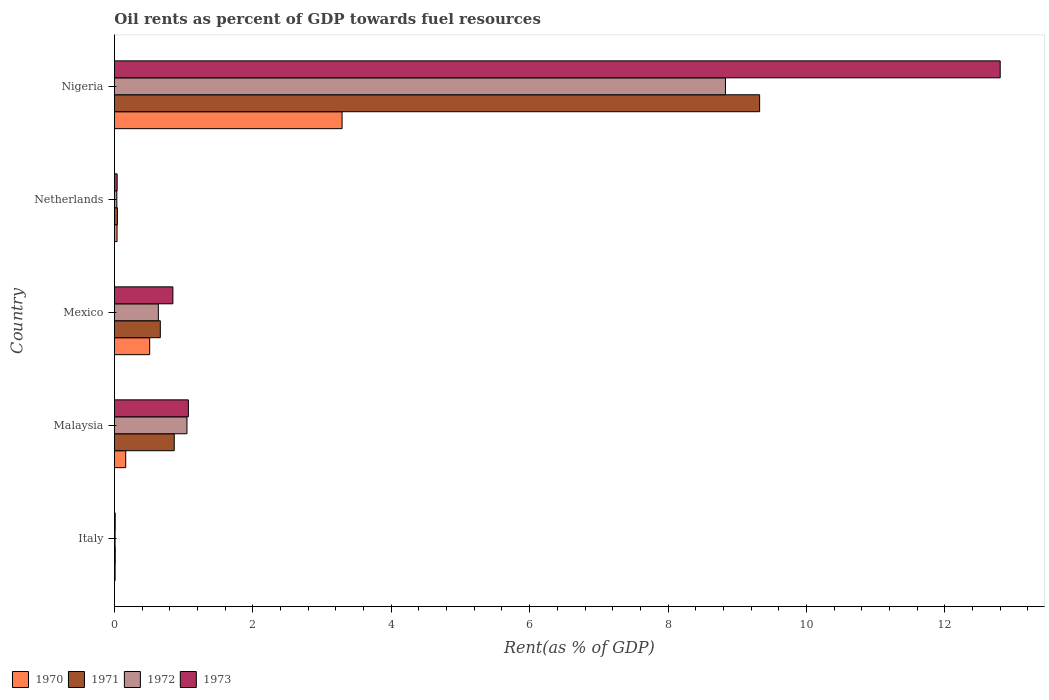How many different coloured bars are there?
Keep it short and to the point. 4. How many groups of bars are there?
Provide a succinct answer. 5. Are the number of bars on each tick of the Y-axis equal?
Give a very brief answer. Yes. How many bars are there on the 5th tick from the bottom?
Give a very brief answer. 4. What is the label of the 3rd group of bars from the top?
Give a very brief answer. Mexico. What is the oil rent in 1972 in Netherlands?
Your response must be concise. 0.03. Across all countries, what is the maximum oil rent in 1972?
Your response must be concise. 8.83. Across all countries, what is the minimum oil rent in 1973?
Ensure brevity in your answer.  0.01. In which country was the oil rent in 1972 maximum?
Provide a succinct answer. Nigeria. What is the total oil rent in 1972 in the graph?
Keep it short and to the point. 10.56. What is the difference between the oil rent in 1971 in Mexico and that in Netherlands?
Your answer should be compact. 0.62. What is the difference between the oil rent in 1973 in Nigeria and the oil rent in 1971 in Italy?
Offer a very short reply. 12.79. What is the average oil rent in 1970 per country?
Ensure brevity in your answer.  0.8. What is the difference between the oil rent in 1972 and oil rent in 1973 in Mexico?
Give a very brief answer. -0.21. In how many countries, is the oil rent in 1970 greater than 6.4 %?
Make the answer very short. 0. What is the ratio of the oil rent in 1970 in Malaysia to that in Nigeria?
Give a very brief answer. 0.05. Is the oil rent in 1970 in Italy less than that in Nigeria?
Offer a very short reply. Yes. What is the difference between the highest and the second highest oil rent in 1970?
Your answer should be very brief. 2.78. What is the difference between the highest and the lowest oil rent in 1971?
Ensure brevity in your answer.  9.31. In how many countries, is the oil rent in 1971 greater than the average oil rent in 1971 taken over all countries?
Your answer should be very brief. 1. Is it the case that in every country, the sum of the oil rent in 1973 and oil rent in 1972 is greater than the sum of oil rent in 1970 and oil rent in 1971?
Ensure brevity in your answer.  No. What does the 3rd bar from the bottom in Nigeria represents?
Offer a terse response. 1972. How many bars are there?
Your answer should be compact. 20. Are all the bars in the graph horizontal?
Ensure brevity in your answer.  Yes. How many countries are there in the graph?
Provide a short and direct response. 5. What is the difference between two consecutive major ticks on the X-axis?
Provide a succinct answer. 2. Does the graph contain any zero values?
Provide a succinct answer. No. What is the title of the graph?
Give a very brief answer. Oil rents as percent of GDP towards fuel resources. Does "1967" appear as one of the legend labels in the graph?
Your answer should be very brief. No. What is the label or title of the X-axis?
Make the answer very short. Rent(as % of GDP). What is the Rent(as % of GDP) in 1970 in Italy?
Make the answer very short. 0.01. What is the Rent(as % of GDP) of 1971 in Italy?
Keep it short and to the point. 0.01. What is the Rent(as % of GDP) in 1972 in Italy?
Your response must be concise. 0.01. What is the Rent(as % of GDP) of 1973 in Italy?
Provide a succinct answer. 0.01. What is the Rent(as % of GDP) of 1970 in Malaysia?
Your answer should be compact. 0.16. What is the Rent(as % of GDP) in 1971 in Malaysia?
Keep it short and to the point. 0.86. What is the Rent(as % of GDP) in 1972 in Malaysia?
Provide a short and direct response. 1.05. What is the Rent(as % of GDP) in 1973 in Malaysia?
Keep it short and to the point. 1.07. What is the Rent(as % of GDP) of 1970 in Mexico?
Make the answer very short. 0.51. What is the Rent(as % of GDP) in 1971 in Mexico?
Ensure brevity in your answer.  0.66. What is the Rent(as % of GDP) in 1972 in Mexico?
Offer a very short reply. 0.63. What is the Rent(as % of GDP) in 1973 in Mexico?
Provide a short and direct response. 0.84. What is the Rent(as % of GDP) in 1970 in Netherlands?
Provide a short and direct response. 0.04. What is the Rent(as % of GDP) of 1971 in Netherlands?
Ensure brevity in your answer.  0.04. What is the Rent(as % of GDP) of 1972 in Netherlands?
Your answer should be compact. 0.03. What is the Rent(as % of GDP) of 1973 in Netherlands?
Your response must be concise. 0.04. What is the Rent(as % of GDP) in 1970 in Nigeria?
Your answer should be compact. 3.29. What is the Rent(as % of GDP) in 1971 in Nigeria?
Offer a very short reply. 9.32. What is the Rent(as % of GDP) in 1972 in Nigeria?
Your answer should be very brief. 8.83. What is the Rent(as % of GDP) in 1973 in Nigeria?
Offer a terse response. 12.8. Across all countries, what is the maximum Rent(as % of GDP) in 1970?
Provide a succinct answer. 3.29. Across all countries, what is the maximum Rent(as % of GDP) in 1971?
Keep it short and to the point. 9.32. Across all countries, what is the maximum Rent(as % of GDP) of 1972?
Ensure brevity in your answer.  8.83. Across all countries, what is the maximum Rent(as % of GDP) of 1973?
Make the answer very short. 12.8. Across all countries, what is the minimum Rent(as % of GDP) in 1970?
Your answer should be compact. 0.01. Across all countries, what is the minimum Rent(as % of GDP) in 1971?
Offer a very short reply. 0.01. Across all countries, what is the minimum Rent(as % of GDP) in 1972?
Keep it short and to the point. 0.01. Across all countries, what is the minimum Rent(as % of GDP) of 1973?
Your answer should be very brief. 0.01. What is the total Rent(as % of GDP) of 1970 in the graph?
Make the answer very short. 4.01. What is the total Rent(as % of GDP) in 1971 in the graph?
Make the answer very short. 10.91. What is the total Rent(as % of GDP) in 1972 in the graph?
Ensure brevity in your answer.  10.56. What is the total Rent(as % of GDP) of 1973 in the graph?
Offer a terse response. 14.76. What is the difference between the Rent(as % of GDP) in 1970 in Italy and that in Malaysia?
Your answer should be very brief. -0.15. What is the difference between the Rent(as % of GDP) of 1971 in Italy and that in Malaysia?
Provide a short and direct response. -0.85. What is the difference between the Rent(as % of GDP) of 1972 in Italy and that in Malaysia?
Your answer should be compact. -1.04. What is the difference between the Rent(as % of GDP) in 1973 in Italy and that in Malaysia?
Your response must be concise. -1.06. What is the difference between the Rent(as % of GDP) in 1970 in Italy and that in Mexico?
Your response must be concise. -0.5. What is the difference between the Rent(as % of GDP) of 1971 in Italy and that in Mexico?
Keep it short and to the point. -0.65. What is the difference between the Rent(as % of GDP) in 1972 in Italy and that in Mexico?
Provide a short and direct response. -0.63. What is the difference between the Rent(as % of GDP) of 1973 in Italy and that in Mexico?
Provide a succinct answer. -0.83. What is the difference between the Rent(as % of GDP) in 1970 in Italy and that in Netherlands?
Give a very brief answer. -0.03. What is the difference between the Rent(as % of GDP) in 1971 in Italy and that in Netherlands?
Make the answer very short. -0.03. What is the difference between the Rent(as % of GDP) in 1972 in Italy and that in Netherlands?
Provide a succinct answer. -0.03. What is the difference between the Rent(as % of GDP) of 1973 in Italy and that in Netherlands?
Provide a succinct answer. -0.03. What is the difference between the Rent(as % of GDP) in 1970 in Italy and that in Nigeria?
Make the answer very short. -3.28. What is the difference between the Rent(as % of GDP) of 1971 in Italy and that in Nigeria?
Your answer should be very brief. -9.31. What is the difference between the Rent(as % of GDP) of 1972 in Italy and that in Nigeria?
Provide a succinct answer. -8.82. What is the difference between the Rent(as % of GDP) of 1973 in Italy and that in Nigeria?
Offer a very short reply. -12.79. What is the difference between the Rent(as % of GDP) in 1970 in Malaysia and that in Mexico?
Your response must be concise. -0.35. What is the difference between the Rent(as % of GDP) of 1971 in Malaysia and that in Mexico?
Keep it short and to the point. 0.2. What is the difference between the Rent(as % of GDP) in 1972 in Malaysia and that in Mexico?
Give a very brief answer. 0.41. What is the difference between the Rent(as % of GDP) in 1973 in Malaysia and that in Mexico?
Keep it short and to the point. 0.22. What is the difference between the Rent(as % of GDP) in 1970 in Malaysia and that in Netherlands?
Provide a succinct answer. 0.13. What is the difference between the Rent(as % of GDP) of 1971 in Malaysia and that in Netherlands?
Ensure brevity in your answer.  0.82. What is the difference between the Rent(as % of GDP) of 1972 in Malaysia and that in Netherlands?
Your answer should be compact. 1.01. What is the difference between the Rent(as % of GDP) in 1973 in Malaysia and that in Netherlands?
Ensure brevity in your answer.  1.03. What is the difference between the Rent(as % of GDP) of 1970 in Malaysia and that in Nigeria?
Keep it short and to the point. -3.13. What is the difference between the Rent(as % of GDP) of 1971 in Malaysia and that in Nigeria?
Ensure brevity in your answer.  -8.46. What is the difference between the Rent(as % of GDP) of 1972 in Malaysia and that in Nigeria?
Ensure brevity in your answer.  -7.78. What is the difference between the Rent(as % of GDP) of 1973 in Malaysia and that in Nigeria?
Make the answer very short. -11.73. What is the difference between the Rent(as % of GDP) of 1970 in Mexico and that in Netherlands?
Your response must be concise. 0.47. What is the difference between the Rent(as % of GDP) in 1971 in Mexico and that in Netherlands?
Offer a terse response. 0.62. What is the difference between the Rent(as % of GDP) in 1972 in Mexico and that in Netherlands?
Provide a succinct answer. 0.6. What is the difference between the Rent(as % of GDP) of 1973 in Mexico and that in Netherlands?
Your response must be concise. 0.81. What is the difference between the Rent(as % of GDP) of 1970 in Mexico and that in Nigeria?
Your response must be concise. -2.78. What is the difference between the Rent(as % of GDP) in 1971 in Mexico and that in Nigeria?
Keep it short and to the point. -8.66. What is the difference between the Rent(as % of GDP) in 1972 in Mexico and that in Nigeria?
Ensure brevity in your answer.  -8.19. What is the difference between the Rent(as % of GDP) in 1973 in Mexico and that in Nigeria?
Make the answer very short. -11.95. What is the difference between the Rent(as % of GDP) in 1970 in Netherlands and that in Nigeria?
Your answer should be very brief. -3.25. What is the difference between the Rent(as % of GDP) of 1971 in Netherlands and that in Nigeria?
Your answer should be very brief. -9.28. What is the difference between the Rent(as % of GDP) in 1972 in Netherlands and that in Nigeria?
Provide a short and direct response. -8.79. What is the difference between the Rent(as % of GDP) of 1973 in Netherlands and that in Nigeria?
Your answer should be very brief. -12.76. What is the difference between the Rent(as % of GDP) in 1970 in Italy and the Rent(as % of GDP) in 1971 in Malaysia?
Keep it short and to the point. -0.85. What is the difference between the Rent(as % of GDP) of 1970 in Italy and the Rent(as % of GDP) of 1972 in Malaysia?
Offer a very short reply. -1.04. What is the difference between the Rent(as % of GDP) in 1970 in Italy and the Rent(as % of GDP) in 1973 in Malaysia?
Offer a very short reply. -1.06. What is the difference between the Rent(as % of GDP) of 1971 in Italy and the Rent(as % of GDP) of 1972 in Malaysia?
Ensure brevity in your answer.  -1.04. What is the difference between the Rent(as % of GDP) of 1971 in Italy and the Rent(as % of GDP) of 1973 in Malaysia?
Make the answer very short. -1.06. What is the difference between the Rent(as % of GDP) in 1972 in Italy and the Rent(as % of GDP) in 1973 in Malaysia?
Your answer should be compact. -1.06. What is the difference between the Rent(as % of GDP) in 1970 in Italy and the Rent(as % of GDP) in 1971 in Mexico?
Offer a terse response. -0.65. What is the difference between the Rent(as % of GDP) in 1970 in Italy and the Rent(as % of GDP) in 1972 in Mexico?
Make the answer very short. -0.62. What is the difference between the Rent(as % of GDP) of 1970 in Italy and the Rent(as % of GDP) of 1973 in Mexico?
Provide a succinct answer. -0.83. What is the difference between the Rent(as % of GDP) in 1971 in Italy and the Rent(as % of GDP) in 1972 in Mexico?
Provide a succinct answer. -0.62. What is the difference between the Rent(as % of GDP) of 1971 in Italy and the Rent(as % of GDP) of 1973 in Mexico?
Provide a succinct answer. -0.83. What is the difference between the Rent(as % of GDP) in 1972 in Italy and the Rent(as % of GDP) in 1973 in Mexico?
Make the answer very short. -0.84. What is the difference between the Rent(as % of GDP) in 1970 in Italy and the Rent(as % of GDP) in 1971 in Netherlands?
Provide a short and direct response. -0.03. What is the difference between the Rent(as % of GDP) of 1970 in Italy and the Rent(as % of GDP) of 1972 in Netherlands?
Your answer should be compact. -0.02. What is the difference between the Rent(as % of GDP) of 1970 in Italy and the Rent(as % of GDP) of 1973 in Netherlands?
Your answer should be very brief. -0.03. What is the difference between the Rent(as % of GDP) in 1971 in Italy and the Rent(as % of GDP) in 1972 in Netherlands?
Your answer should be compact. -0.02. What is the difference between the Rent(as % of GDP) in 1971 in Italy and the Rent(as % of GDP) in 1973 in Netherlands?
Offer a very short reply. -0.03. What is the difference between the Rent(as % of GDP) in 1972 in Italy and the Rent(as % of GDP) in 1973 in Netherlands?
Give a very brief answer. -0.03. What is the difference between the Rent(as % of GDP) of 1970 in Italy and the Rent(as % of GDP) of 1971 in Nigeria?
Make the answer very short. -9.31. What is the difference between the Rent(as % of GDP) in 1970 in Italy and the Rent(as % of GDP) in 1972 in Nigeria?
Make the answer very short. -8.82. What is the difference between the Rent(as % of GDP) in 1970 in Italy and the Rent(as % of GDP) in 1973 in Nigeria?
Provide a short and direct response. -12.79. What is the difference between the Rent(as % of GDP) in 1971 in Italy and the Rent(as % of GDP) in 1972 in Nigeria?
Offer a terse response. -8.82. What is the difference between the Rent(as % of GDP) of 1971 in Italy and the Rent(as % of GDP) of 1973 in Nigeria?
Give a very brief answer. -12.79. What is the difference between the Rent(as % of GDP) in 1972 in Italy and the Rent(as % of GDP) in 1973 in Nigeria?
Your answer should be very brief. -12.79. What is the difference between the Rent(as % of GDP) of 1970 in Malaysia and the Rent(as % of GDP) of 1971 in Mexico?
Give a very brief answer. -0.5. What is the difference between the Rent(as % of GDP) in 1970 in Malaysia and the Rent(as % of GDP) in 1972 in Mexico?
Provide a succinct answer. -0.47. What is the difference between the Rent(as % of GDP) in 1970 in Malaysia and the Rent(as % of GDP) in 1973 in Mexico?
Keep it short and to the point. -0.68. What is the difference between the Rent(as % of GDP) in 1971 in Malaysia and the Rent(as % of GDP) in 1972 in Mexico?
Your response must be concise. 0.23. What is the difference between the Rent(as % of GDP) of 1971 in Malaysia and the Rent(as % of GDP) of 1973 in Mexico?
Make the answer very short. 0.02. What is the difference between the Rent(as % of GDP) in 1972 in Malaysia and the Rent(as % of GDP) in 1973 in Mexico?
Offer a very short reply. 0.2. What is the difference between the Rent(as % of GDP) in 1970 in Malaysia and the Rent(as % of GDP) in 1971 in Netherlands?
Your response must be concise. 0.12. What is the difference between the Rent(as % of GDP) of 1970 in Malaysia and the Rent(as % of GDP) of 1972 in Netherlands?
Offer a very short reply. 0.13. What is the difference between the Rent(as % of GDP) in 1970 in Malaysia and the Rent(as % of GDP) in 1973 in Netherlands?
Give a very brief answer. 0.12. What is the difference between the Rent(as % of GDP) of 1971 in Malaysia and the Rent(as % of GDP) of 1972 in Netherlands?
Provide a succinct answer. 0.83. What is the difference between the Rent(as % of GDP) in 1971 in Malaysia and the Rent(as % of GDP) in 1973 in Netherlands?
Provide a short and direct response. 0.82. What is the difference between the Rent(as % of GDP) of 1972 in Malaysia and the Rent(as % of GDP) of 1973 in Netherlands?
Keep it short and to the point. 1.01. What is the difference between the Rent(as % of GDP) of 1970 in Malaysia and the Rent(as % of GDP) of 1971 in Nigeria?
Your answer should be compact. -9.16. What is the difference between the Rent(as % of GDP) of 1970 in Malaysia and the Rent(as % of GDP) of 1972 in Nigeria?
Offer a terse response. -8.67. What is the difference between the Rent(as % of GDP) of 1970 in Malaysia and the Rent(as % of GDP) of 1973 in Nigeria?
Provide a succinct answer. -12.64. What is the difference between the Rent(as % of GDP) of 1971 in Malaysia and the Rent(as % of GDP) of 1972 in Nigeria?
Provide a short and direct response. -7.96. What is the difference between the Rent(as % of GDP) of 1971 in Malaysia and the Rent(as % of GDP) of 1973 in Nigeria?
Your answer should be very brief. -11.94. What is the difference between the Rent(as % of GDP) in 1972 in Malaysia and the Rent(as % of GDP) in 1973 in Nigeria?
Your answer should be compact. -11.75. What is the difference between the Rent(as % of GDP) of 1970 in Mexico and the Rent(as % of GDP) of 1971 in Netherlands?
Keep it short and to the point. 0.47. What is the difference between the Rent(as % of GDP) in 1970 in Mexico and the Rent(as % of GDP) in 1972 in Netherlands?
Your answer should be compact. 0.47. What is the difference between the Rent(as % of GDP) of 1970 in Mexico and the Rent(as % of GDP) of 1973 in Netherlands?
Give a very brief answer. 0.47. What is the difference between the Rent(as % of GDP) in 1971 in Mexico and the Rent(as % of GDP) in 1972 in Netherlands?
Provide a short and direct response. 0.63. What is the difference between the Rent(as % of GDP) of 1971 in Mexico and the Rent(as % of GDP) of 1973 in Netherlands?
Ensure brevity in your answer.  0.62. What is the difference between the Rent(as % of GDP) of 1972 in Mexico and the Rent(as % of GDP) of 1973 in Netherlands?
Offer a very short reply. 0.6. What is the difference between the Rent(as % of GDP) in 1970 in Mexico and the Rent(as % of GDP) in 1971 in Nigeria?
Your answer should be very brief. -8.81. What is the difference between the Rent(as % of GDP) in 1970 in Mexico and the Rent(as % of GDP) in 1972 in Nigeria?
Offer a very short reply. -8.32. What is the difference between the Rent(as % of GDP) in 1970 in Mexico and the Rent(as % of GDP) in 1973 in Nigeria?
Your answer should be very brief. -12.29. What is the difference between the Rent(as % of GDP) in 1971 in Mexico and the Rent(as % of GDP) in 1972 in Nigeria?
Your answer should be very brief. -8.17. What is the difference between the Rent(as % of GDP) of 1971 in Mexico and the Rent(as % of GDP) of 1973 in Nigeria?
Your answer should be compact. -12.14. What is the difference between the Rent(as % of GDP) of 1972 in Mexico and the Rent(as % of GDP) of 1973 in Nigeria?
Keep it short and to the point. -12.16. What is the difference between the Rent(as % of GDP) of 1970 in Netherlands and the Rent(as % of GDP) of 1971 in Nigeria?
Provide a short and direct response. -9.29. What is the difference between the Rent(as % of GDP) of 1970 in Netherlands and the Rent(as % of GDP) of 1972 in Nigeria?
Your response must be concise. -8.79. What is the difference between the Rent(as % of GDP) in 1970 in Netherlands and the Rent(as % of GDP) in 1973 in Nigeria?
Make the answer very short. -12.76. What is the difference between the Rent(as % of GDP) of 1971 in Netherlands and the Rent(as % of GDP) of 1972 in Nigeria?
Provide a short and direct response. -8.79. What is the difference between the Rent(as % of GDP) of 1971 in Netherlands and the Rent(as % of GDP) of 1973 in Nigeria?
Your answer should be very brief. -12.76. What is the difference between the Rent(as % of GDP) of 1972 in Netherlands and the Rent(as % of GDP) of 1973 in Nigeria?
Ensure brevity in your answer.  -12.76. What is the average Rent(as % of GDP) in 1970 per country?
Offer a terse response. 0.8. What is the average Rent(as % of GDP) of 1971 per country?
Your answer should be compact. 2.18. What is the average Rent(as % of GDP) of 1972 per country?
Offer a terse response. 2.11. What is the average Rent(as % of GDP) in 1973 per country?
Your answer should be compact. 2.95. What is the difference between the Rent(as % of GDP) of 1970 and Rent(as % of GDP) of 1971 in Italy?
Provide a succinct answer. -0. What is the difference between the Rent(as % of GDP) in 1970 and Rent(as % of GDP) in 1972 in Italy?
Offer a very short reply. 0. What is the difference between the Rent(as % of GDP) of 1970 and Rent(as % of GDP) of 1973 in Italy?
Provide a succinct answer. -0. What is the difference between the Rent(as % of GDP) in 1971 and Rent(as % of GDP) in 1972 in Italy?
Your answer should be compact. 0. What is the difference between the Rent(as % of GDP) in 1972 and Rent(as % of GDP) in 1973 in Italy?
Ensure brevity in your answer.  -0. What is the difference between the Rent(as % of GDP) in 1970 and Rent(as % of GDP) in 1971 in Malaysia?
Offer a very short reply. -0.7. What is the difference between the Rent(as % of GDP) of 1970 and Rent(as % of GDP) of 1972 in Malaysia?
Offer a terse response. -0.89. What is the difference between the Rent(as % of GDP) of 1970 and Rent(as % of GDP) of 1973 in Malaysia?
Offer a terse response. -0.91. What is the difference between the Rent(as % of GDP) of 1971 and Rent(as % of GDP) of 1972 in Malaysia?
Your response must be concise. -0.18. What is the difference between the Rent(as % of GDP) of 1971 and Rent(as % of GDP) of 1973 in Malaysia?
Make the answer very short. -0.2. What is the difference between the Rent(as % of GDP) of 1972 and Rent(as % of GDP) of 1973 in Malaysia?
Ensure brevity in your answer.  -0.02. What is the difference between the Rent(as % of GDP) of 1970 and Rent(as % of GDP) of 1971 in Mexico?
Ensure brevity in your answer.  -0.15. What is the difference between the Rent(as % of GDP) in 1970 and Rent(as % of GDP) in 1972 in Mexico?
Your answer should be compact. -0.13. What is the difference between the Rent(as % of GDP) in 1970 and Rent(as % of GDP) in 1973 in Mexico?
Give a very brief answer. -0.34. What is the difference between the Rent(as % of GDP) in 1971 and Rent(as % of GDP) in 1972 in Mexico?
Your answer should be compact. 0.03. What is the difference between the Rent(as % of GDP) in 1971 and Rent(as % of GDP) in 1973 in Mexico?
Provide a succinct answer. -0.18. What is the difference between the Rent(as % of GDP) of 1972 and Rent(as % of GDP) of 1973 in Mexico?
Give a very brief answer. -0.21. What is the difference between the Rent(as % of GDP) of 1970 and Rent(as % of GDP) of 1971 in Netherlands?
Make the answer very short. -0.01. What is the difference between the Rent(as % of GDP) of 1970 and Rent(as % of GDP) of 1972 in Netherlands?
Ensure brevity in your answer.  0. What is the difference between the Rent(as % of GDP) in 1970 and Rent(as % of GDP) in 1973 in Netherlands?
Offer a terse response. -0. What is the difference between the Rent(as % of GDP) in 1971 and Rent(as % of GDP) in 1972 in Netherlands?
Your answer should be very brief. 0.01. What is the difference between the Rent(as % of GDP) in 1971 and Rent(as % of GDP) in 1973 in Netherlands?
Make the answer very short. 0. What is the difference between the Rent(as % of GDP) of 1972 and Rent(as % of GDP) of 1973 in Netherlands?
Offer a terse response. -0. What is the difference between the Rent(as % of GDP) in 1970 and Rent(as % of GDP) in 1971 in Nigeria?
Keep it short and to the point. -6.03. What is the difference between the Rent(as % of GDP) in 1970 and Rent(as % of GDP) in 1972 in Nigeria?
Your answer should be very brief. -5.54. What is the difference between the Rent(as % of GDP) in 1970 and Rent(as % of GDP) in 1973 in Nigeria?
Your response must be concise. -9.51. What is the difference between the Rent(as % of GDP) of 1971 and Rent(as % of GDP) of 1972 in Nigeria?
Your response must be concise. 0.49. What is the difference between the Rent(as % of GDP) of 1971 and Rent(as % of GDP) of 1973 in Nigeria?
Provide a short and direct response. -3.48. What is the difference between the Rent(as % of GDP) of 1972 and Rent(as % of GDP) of 1973 in Nigeria?
Give a very brief answer. -3.97. What is the ratio of the Rent(as % of GDP) in 1970 in Italy to that in Malaysia?
Offer a very short reply. 0.06. What is the ratio of the Rent(as % of GDP) of 1971 in Italy to that in Malaysia?
Offer a terse response. 0.01. What is the ratio of the Rent(as % of GDP) of 1972 in Italy to that in Malaysia?
Give a very brief answer. 0.01. What is the ratio of the Rent(as % of GDP) of 1973 in Italy to that in Malaysia?
Your answer should be compact. 0.01. What is the ratio of the Rent(as % of GDP) of 1970 in Italy to that in Mexico?
Your answer should be compact. 0.02. What is the ratio of the Rent(as % of GDP) in 1971 in Italy to that in Mexico?
Ensure brevity in your answer.  0.02. What is the ratio of the Rent(as % of GDP) of 1972 in Italy to that in Mexico?
Make the answer very short. 0.01. What is the ratio of the Rent(as % of GDP) of 1973 in Italy to that in Mexico?
Offer a very short reply. 0.01. What is the ratio of the Rent(as % of GDP) in 1970 in Italy to that in Netherlands?
Your answer should be compact. 0.26. What is the ratio of the Rent(as % of GDP) in 1971 in Italy to that in Netherlands?
Offer a very short reply. 0.27. What is the ratio of the Rent(as % of GDP) in 1972 in Italy to that in Netherlands?
Offer a very short reply. 0.27. What is the ratio of the Rent(as % of GDP) in 1973 in Italy to that in Netherlands?
Keep it short and to the point. 0.28. What is the ratio of the Rent(as % of GDP) of 1970 in Italy to that in Nigeria?
Keep it short and to the point. 0. What is the ratio of the Rent(as % of GDP) in 1971 in Italy to that in Nigeria?
Give a very brief answer. 0. What is the ratio of the Rent(as % of GDP) of 1972 in Italy to that in Nigeria?
Give a very brief answer. 0. What is the ratio of the Rent(as % of GDP) of 1973 in Italy to that in Nigeria?
Your response must be concise. 0. What is the ratio of the Rent(as % of GDP) of 1970 in Malaysia to that in Mexico?
Ensure brevity in your answer.  0.32. What is the ratio of the Rent(as % of GDP) in 1971 in Malaysia to that in Mexico?
Ensure brevity in your answer.  1.3. What is the ratio of the Rent(as % of GDP) of 1972 in Malaysia to that in Mexico?
Your answer should be compact. 1.65. What is the ratio of the Rent(as % of GDP) in 1973 in Malaysia to that in Mexico?
Provide a short and direct response. 1.27. What is the ratio of the Rent(as % of GDP) in 1970 in Malaysia to that in Netherlands?
Ensure brevity in your answer.  4.3. What is the ratio of the Rent(as % of GDP) in 1971 in Malaysia to that in Netherlands?
Make the answer very short. 20.04. What is the ratio of the Rent(as % of GDP) of 1972 in Malaysia to that in Netherlands?
Offer a terse response. 30.19. What is the ratio of the Rent(as % of GDP) in 1973 in Malaysia to that in Netherlands?
Your response must be concise. 27.06. What is the ratio of the Rent(as % of GDP) of 1970 in Malaysia to that in Nigeria?
Your answer should be compact. 0.05. What is the ratio of the Rent(as % of GDP) of 1971 in Malaysia to that in Nigeria?
Keep it short and to the point. 0.09. What is the ratio of the Rent(as % of GDP) in 1972 in Malaysia to that in Nigeria?
Keep it short and to the point. 0.12. What is the ratio of the Rent(as % of GDP) of 1973 in Malaysia to that in Nigeria?
Provide a succinct answer. 0.08. What is the ratio of the Rent(as % of GDP) in 1970 in Mexico to that in Netherlands?
Your answer should be compact. 13.43. What is the ratio of the Rent(as % of GDP) in 1971 in Mexico to that in Netherlands?
Your answer should be compact. 15.37. What is the ratio of the Rent(as % of GDP) in 1972 in Mexico to that in Netherlands?
Provide a succinct answer. 18.28. What is the ratio of the Rent(as % of GDP) in 1973 in Mexico to that in Netherlands?
Give a very brief answer. 21.38. What is the ratio of the Rent(as % of GDP) in 1970 in Mexico to that in Nigeria?
Your answer should be very brief. 0.15. What is the ratio of the Rent(as % of GDP) of 1971 in Mexico to that in Nigeria?
Your answer should be very brief. 0.07. What is the ratio of the Rent(as % of GDP) of 1972 in Mexico to that in Nigeria?
Offer a very short reply. 0.07. What is the ratio of the Rent(as % of GDP) in 1973 in Mexico to that in Nigeria?
Provide a succinct answer. 0.07. What is the ratio of the Rent(as % of GDP) of 1970 in Netherlands to that in Nigeria?
Ensure brevity in your answer.  0.01. What is the ratio of the Rent(as % of GDP) of 1971 in Netherlands to that in Nigeria?
Keep it short and to the point. 0. What is the ratio of the Rent(as % of GDP) in 1972 in Netherlands to that in Nigeria?
Your answer should be compact. 0. What is the ratio of the Rent(as % of GDP) of 1973 in Netherlands to that in Nigeria?
Your response must be concise. 0. What is the difference between the highest and the second highest Rent(as % of GDP) of 1970?
Keep it short and to the point. 2.78. What is the difference between the highest and the second highest Rent(as % of GDP) in 1971?
Give a very brief answer. 8.46. What is the difference between the highest and the second highest Rent(as % of GDP) in 1972?
Provide a succinct answer. 7.78. What is the difference between the highest and the second highest Rent(as % of GDP) of 1973?
Your response must be concise. 11.73. What is the difference between the highest and the lowest Rent(as % of GDP) in 1970?
Offer a very short reply. 3.28. What is the difference between the highest and the lowest Rent(as % of GDP) of 1971?
Offer a terse response. 9.31. What is the difference between the highest and the lowest Rent(as % of GDP) in 1972?
Your response must be concise. 8.82. What is the difference between the highest and the lowest Rent(as % of GDP) in 1973?
Provide a succinct answer. 12.79. 